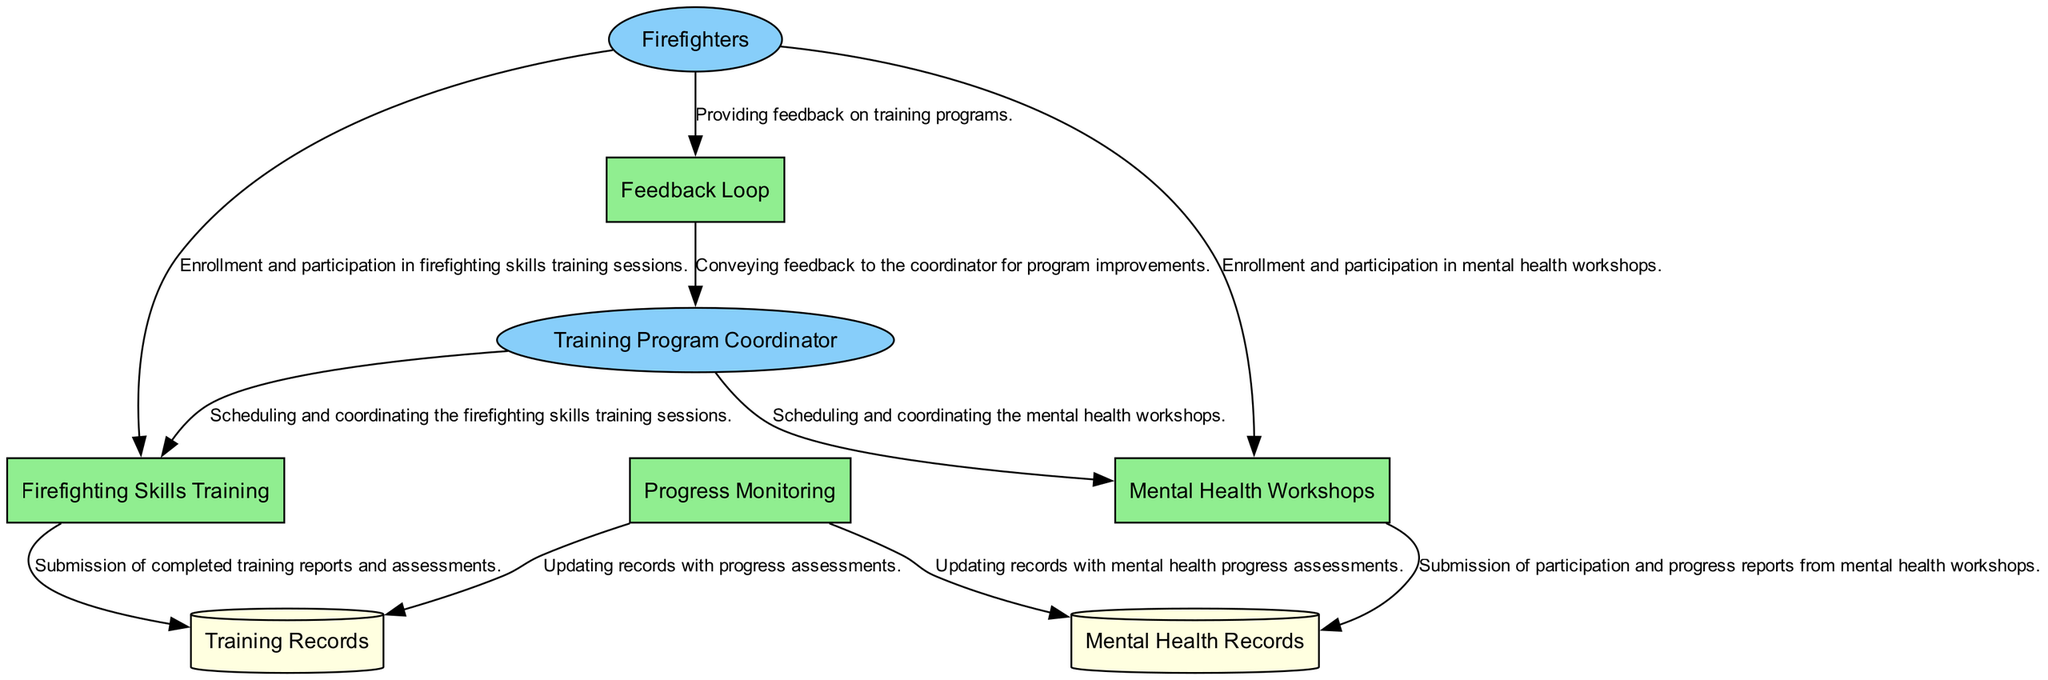What is the first process in the training program? The first process listed in the diagram is "Firefighting Skills Training." It is explicitly stated at the start of the process list.
Answer: Firefighting Skills Training How many external entities are present in the diagram? There are two external entities: Firefighters and Training Program Coordinator. This can be counted directly from the entities section.
Answer: 2 What type of data is stored in the "Mental Health Records"? The "Mental Health Records" store contains records related to mental health assessments and workshops participation, as described in the data store section.
Answer: Records related to mental health assessments and workshops participation Which process updates the "Training Records"? The "Progress Monitoring" process updates the "Training Records," as indicated by the data flow connecting them in the diagram.
Answer: Progress Monitoring What is the relationship between "Firefighters" and "Feedback Loop"? The relationship is that Firefighters provide feedback on training programs to the Feedback Loop, based on the data flow description in the diagram.
Answer: Firefighters provide feedback What information is conveyed to the Training Program Coordinator through the "Feedback Loop"? The Feedback Loop conveys feedback from firefighters to the Training Program Coordinator for program improvements, as described in the data flow between these two entities.
Answer: Feedback for program improvements How many processes involve mental health components? There are two processes that involve mental health components: "Mental Health Workshops" and "Progress Monitoring." This can be directly observed in the processes section of the diagram.
Answer: 2 What type of data does "Firefighting Skills Training" send to "Training Records"? "Firefighting Skills Training" sends completed training reports and assessments to "Training Records," as stated in the data flow explanation connecting these entities.
Answer: Completed training reports and assessments What is the flow direction from "Mental Health Workshops" to "Mental Health Records"? The flow direction is from "Mental Health Workshops" to "Mental Health Records," indicating that data is submitted from workshops to the records. This is documented in the data flow section.
Answer: From Mental Health Workshops to Mental Health Records 